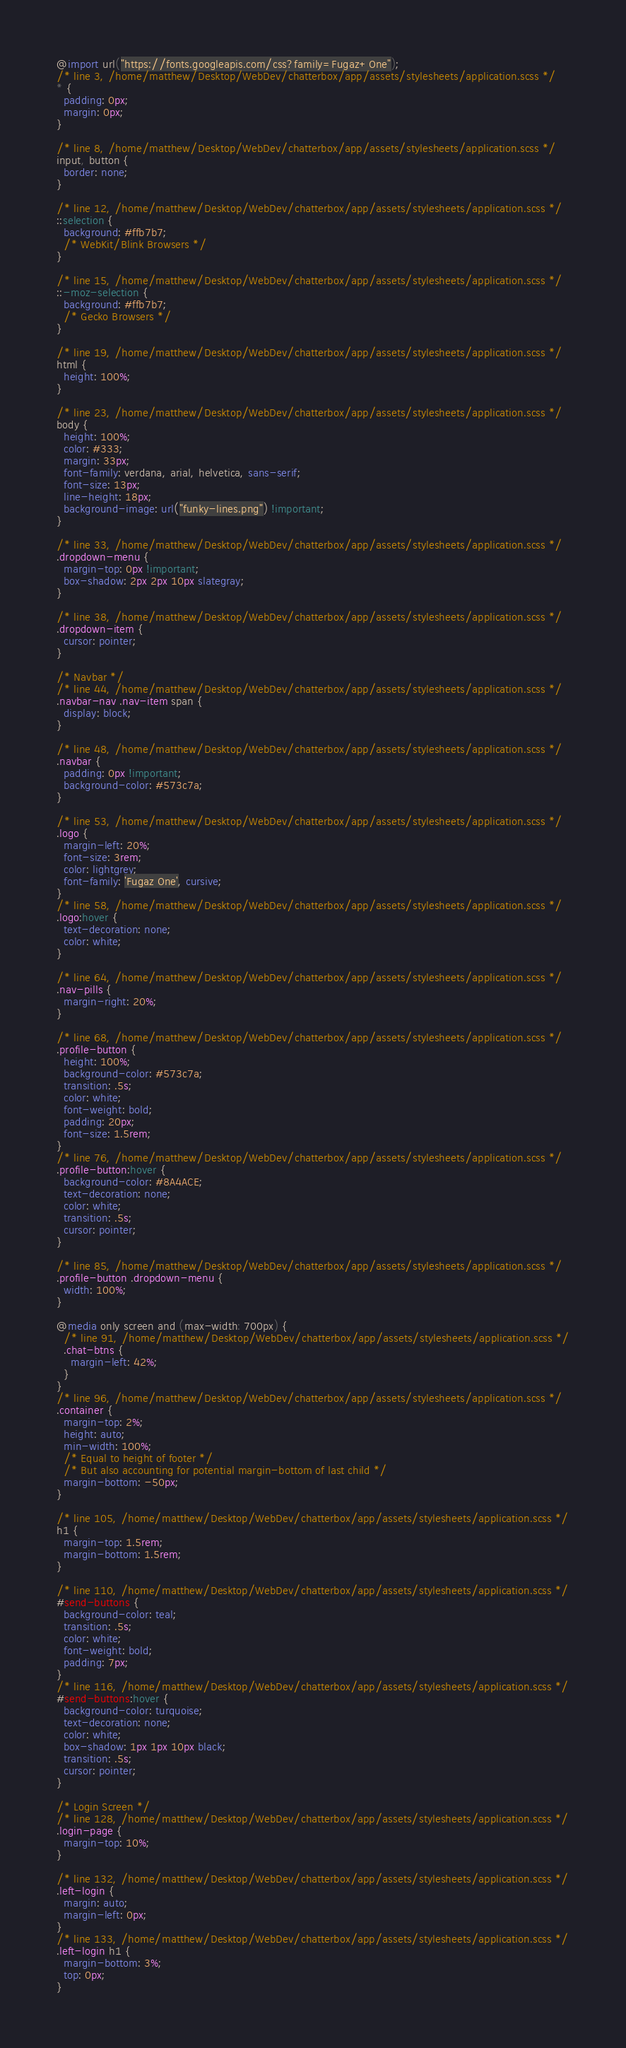<code> <loc_0><loc_0><loc_500><loc_500><_CSS_>@import url("https://fonts.googleapis.com/css?family=Fugaz+One");
/* line 3, /home/matthew/Desktop/WebDev/chatterbox/app/assets/stylesheets/application.scss */
* {
  padding: 0px;
  margin: 0px;
}

/* line 8, /home/matthew/Desktop/WebDev/chatterbox/app/assets/stylesheets/application.scss */
input, button {
  border: none;
}

/* line 12, /home/matthew/Desktop/WebDev/chatterbox/app/assets/stylesheets/application.scss */
::selection {
  background: #ffb7b7;
  /* WebKit/Blink Browsers */
}

/* line 15, /home/matthew/Desktop/WebDev/chatterbox/app/assets/stylesheets/application.scss */
::-moz-selection {
  background: #ffb7b7;
  /* Gecko Browsers */
}

/* line 19, /home/matthew/Desktop/WebDev/chatterbox/app/assets/stylesheets/application.scss */
html {
  height: 100%;
}

/* line 23, /home/matthew/Desktop/WebDev/chatterbox/app/assets/stylesheets/application.scss */
body {
  height: 100%;
  color: #333;
  margin: 33px;
  font-family: verdana, arial, helvetica, sans-serif;
  font-size: 13px;
  line-height: 18px;
  background-image: url("funky-lines.png") !important;
}

/* line 33, /home/matthew/Desktop/WebDev/chatterbox/app/assets/stylesheets/application.scss */
.dropdown-menu {
  margin-top: 0px !important;
  box-shadow: 2px 2px 10px slategray;
}

/* line 38, /home/matthew/Desktop/WebDev/chatterbox/app/assets/stylesheets/application.scss */
.dropdown-item {
  cursor: pointer;
}

/* Navbar */
/* line 44, /home/matthew/Desktop/WebDev/chatterbox/app/assets/stylesheets/application.scss */
.navbar-nav .nav-item span {
  display: block;
}

/* line 48, /home/matthew/Desktop/WebDev/chatterbox/app/assets/stylesheets/application.scss */
.navbar {
  padding: 0px !important;
  background-color: #573c7a;
}

/* line 53, /home/matthew/Desktop/WebDev/chatterbox/app/assets/stylesheets/application.scss */
.logo {
  margin-left: 20%;
  font-size: 3rem;
  color: lightgrey;
  font-family: 'Fugaz One', cursive;
}
/* line 58, /home/matthew/Desktop/WebDev/chatterbox/app/assets/stylesheets/application.scss */
.logo:hover {
  text-decoration: none;
  color: white;
}

/* line 64, /home/matthew/Desktop/WebDev/chatterbox/app/assets/stylesheets/application.scss */
.nav-pills {
  margin-right: 20%;
}

/* line 68, /home/matthew/Desktop/WebDev/chatterbox/app/assets/stylesheets/application.scss */
.profile-button {
  height: 100%;
  background-color: #573c7a;
  transition: .5s;
  color: white;
  font-weight: bold;
  padding: 20px;
  font-size: 1.5rem;
}
/* line 76, /home/matthew/Desktop/WebDev/chatterbox/app/assets/stylesheets/application.scss */
.profile-button:hover {
  background-color: #8A4ACE;
  text-decoration: none;
  color: white;
  transition: .5s;
  cursor: pointer;
}

/* line 85, /home/matthew/Desktop/WebDev/chatterbox/app/assets/stylesheets/application.scss */
.profile-button .dropdown-menu {
  width: 100%;
}

@media only screen and (max-width: 700px) {
  /* line 91, /home/matthew/Desktop/WebDev/chatterbox/app/assets/stylesheets/application.scss */
  .chat-btns {
    margin-left: 42%;
  }
}
/* line 96, /home/matthew/Desktop/WebDev/chatterbox/app/assets/stylesheets/application.scss */
.container {
  margin-top: 2%;
  height: auto;
  min-width: 100%;
  /* Equal to height of footer */
  /* But also accounting for potential margin-bottom of last child */
  margin-bottom: -50px;
}

/* line 105, /home/matthew/Desktop/WebDev/chatterbox/app/assets/stylesheets/application.scss */
h1 {
  margin-top: 1.5rem;
  margin-bottom: 1.5rem;
}

/* line 110, /home/matthew/Desktop/WebDev/chatterbox/app/assets/stylesheets/application.scss */
#send-buttons {
  background-color: teal;
  transition: .5s;
  color: white;
  font-weight: bold;
  padding: 7px;
}
/* line 116, /home/matthew/Desktop/WebDev/chatterbox/app/assets/stylesheets/application.scss */
#send-buttons:hover {
  background-color: turquoise;
  text-decoration: none;
  color: white;
  box-shadow: 1px 1px 10px black;
  transition: .5s;
  cursor: pointer;
}

/* Login Screen */
/* line 128, /home/matthew/Desktop/WebDev/chatterbox/app/assets/stylesheets/application.scss */
.login-page {
  margin-top: 10%;
}

/* line 132, /home/matthew/Desktop/WebDev/chatterbox/app/assets/stylesheets/application.scss */
.left-login {
  margin: auto;
  margin-left: 0px;
}
/* line 133, /home/matthew/Desktop/WebDev/chatterbox/app/assets/stylesheets/application.scss */
.left-login h1 {
  margin-bottom: 3%;
  top: 0px;
}
</code> 